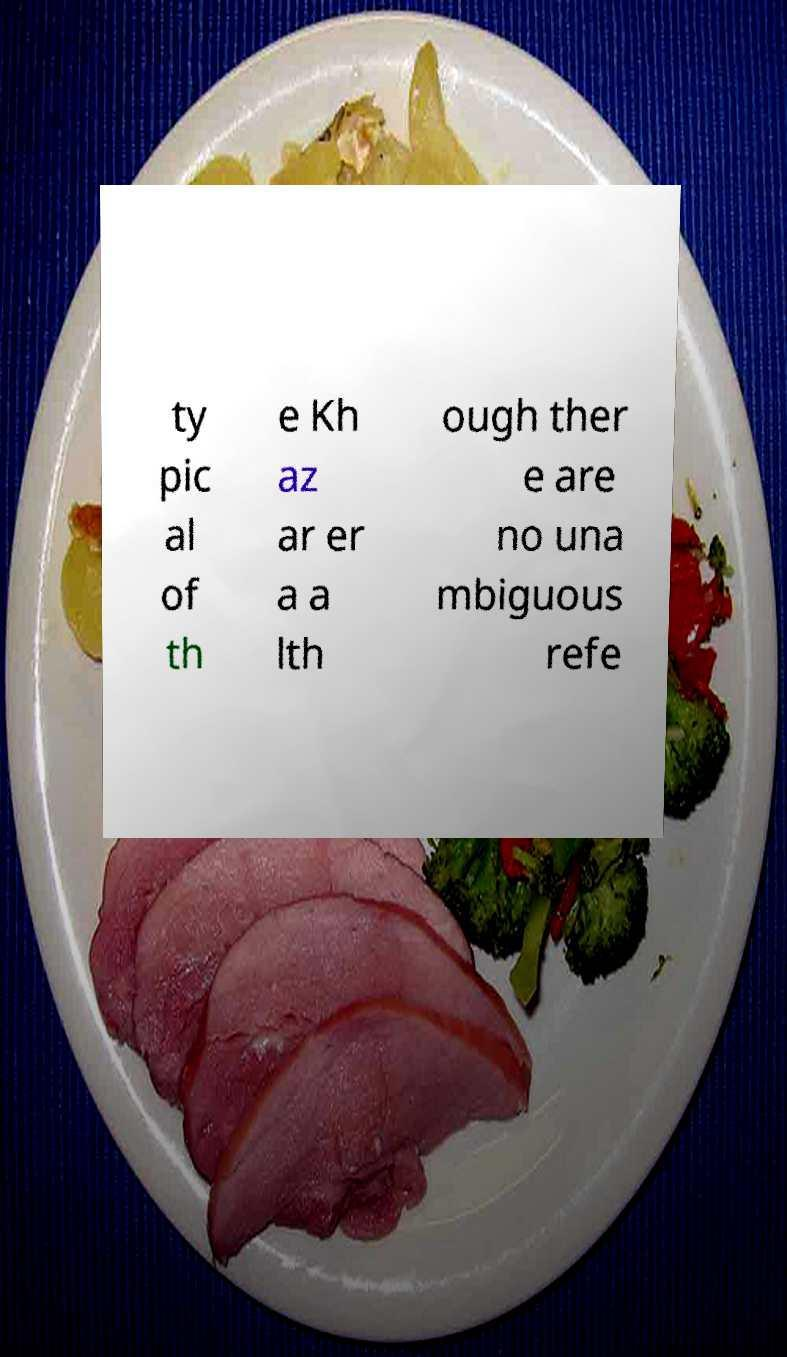I need the written content from this picture converted into text. Can you do that? ty pic al of th e Kh az ar er a a lth ough ther e are no una mbiguous refe 